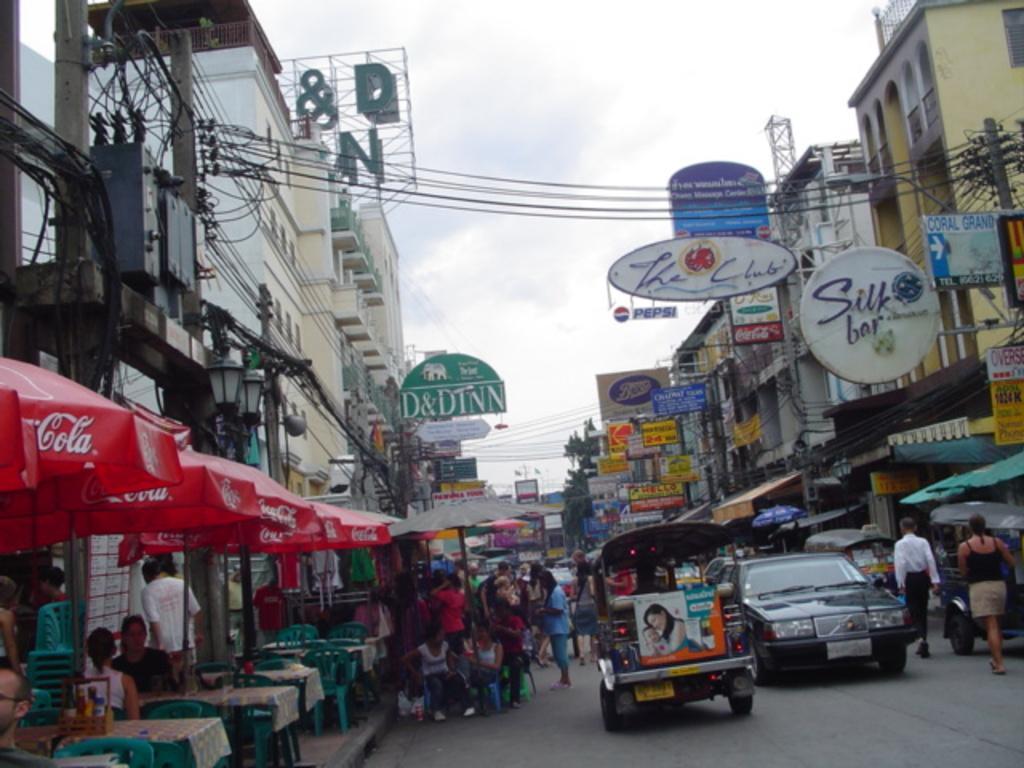Can you describe this image briefly? In this image I can see few buildings, current polls, few wires, transformer, colorful boards, red color umbrellas, few tables, few chairs, vehicles, sheds, few people are sitting on the chairs and few are walking on the road. The sky is in blue and white color. 